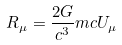<formula> <loc_0><loc_0><loc_500><loc_500>R _ { \mu } = \frac { 2 G } { c ^ { 3 } } m c U _ { \mu }</formula> 